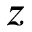<formula> <loc_0><loc_0><loc_500><loc_500>z</formula> 